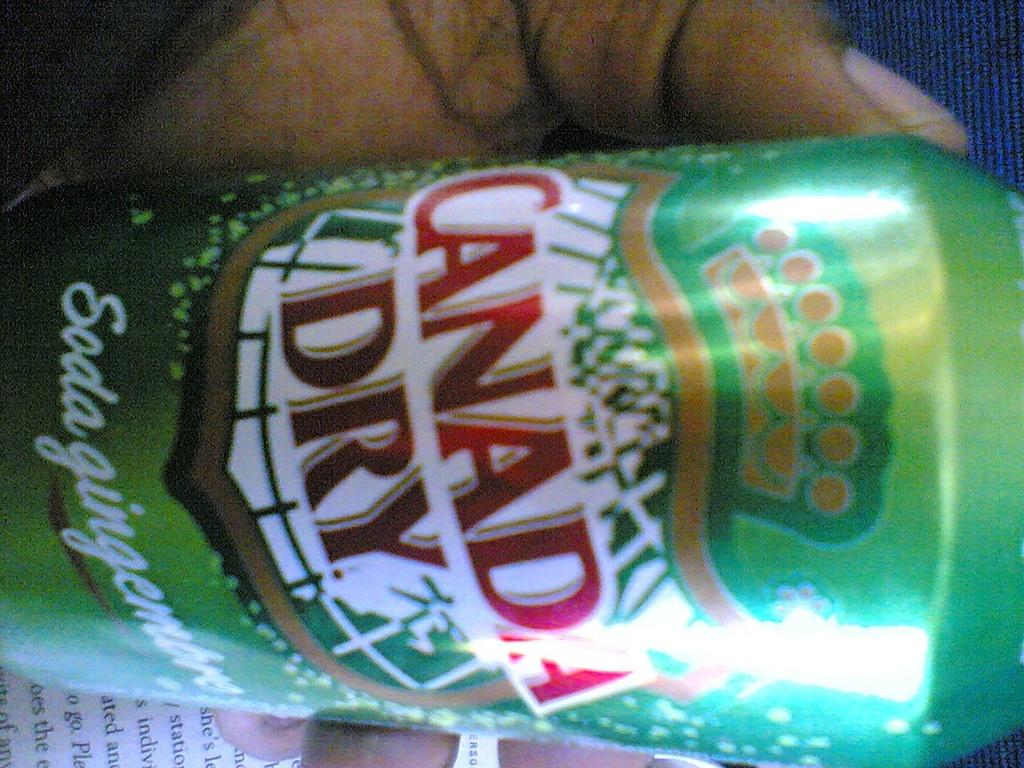What country does this drink come from?
Your answer should be very brief. Canada. What kind of soda is this?
Ensure brevity in your answer.  Canada dry. 